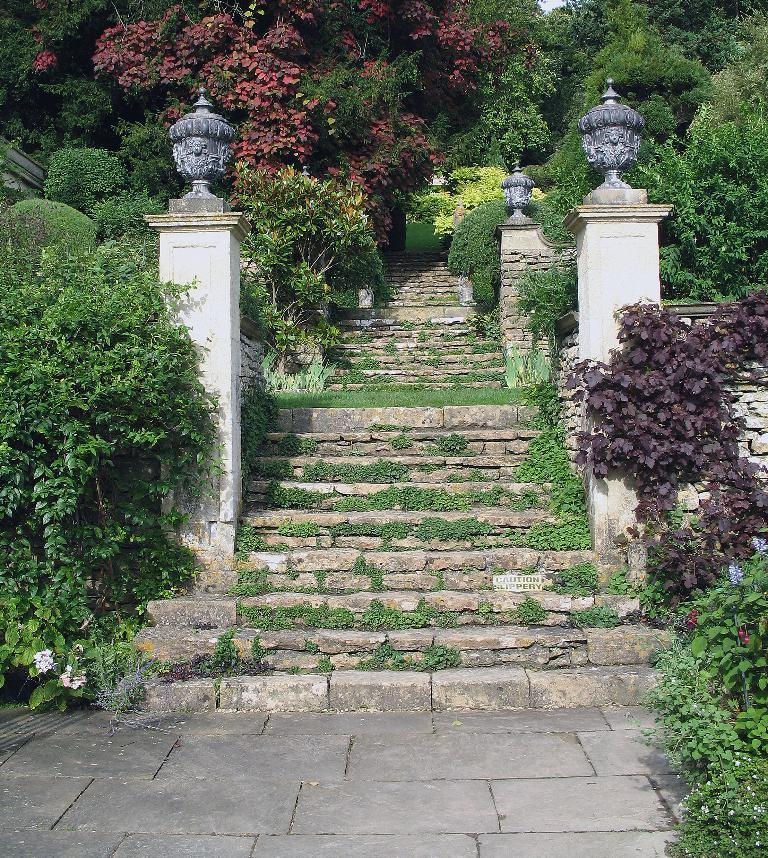What type of natural elements can be seen in the image? There are trees and plants in the image. Where are the trees and plants located in the image? The trees and plants are on the left and right sides of the image. What is in the middle of the image? There is a walkway in the middle of the image. What architectural features are present in the image? There are walls in the image, and lamps are present on the walls. What type of instrument is being played in the image? There is no instrument being played in the image; it primarily features trees, plants, a walkway, walls, and lamps. 